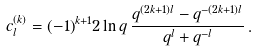<formula> <loc_0><loc_0><loc_500><loc_500>c _ { l } ^ { ( k ) } = ( - 1 ) ^ { k + 1 } 2 \ln q \, \frac { q ^ { ( 2 k + 1 ) l } - q ^ { - ( 2 k + 1 ) l } } { q ^ { l } + q ^ { - l } } \, .</formula> 